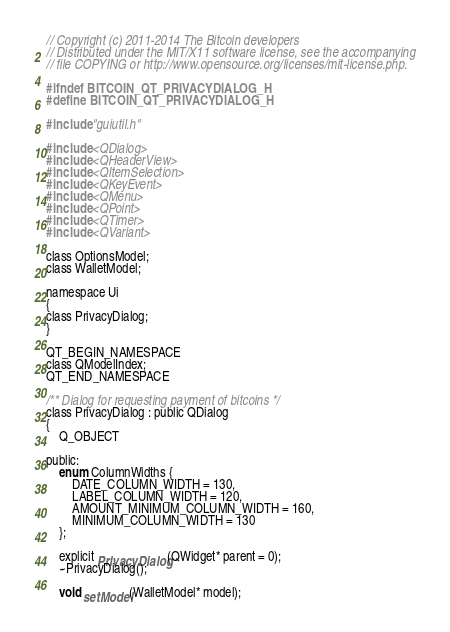<code> <loc_0><loc_0><loc_500><loc_500><_C_>// Copyright (c) 2011-2014 The Bitcoin developers
// Distributed under the MIT/X11 software license, see the accompanying
// file COPYING or http://www.opensource.org/licenses/mit-license.php.

#ifndef BITCOIN_QT_PRIVACYDIALOG_H
#define BITCOIN_QT_PRIVACYDIALOG_H

#include "guiutil.h"

#include <QDialog>
#include <QHeaderView>
#include <QItemSelection>
#include <QKeyEvent>
#include <QMenu>
#include <QPoint>
#include <QTimer>
#include <QVariant>

class OptionsModel;
class WalletModel;

namespace Ui
{
class PrivacyDialog;
}

QT_BEGIN_NAMESPACE
class QModelIndex;
QT_END_NAMESPACE

/** Dialog for requesting payment of bitcoins */
class PrivacyDialog : public QDialog
{
    Q_OBJECT

public:
    enum ColumnWidths {
        DATE_COLUMN_WIDTH = 130,
        LABEL_COLUMN_WIDTH = 120,
        AMOUNT_MINIMUM_COLUMN_WIDTH = 160,
        MINIMUM_COLUMN_WIDTH = 130
    };

    explicit PrivacyDialog(QWidget* parent = 0);
    ~PrivacyDialog();

    void setModel(WalletModel* model);</code> 